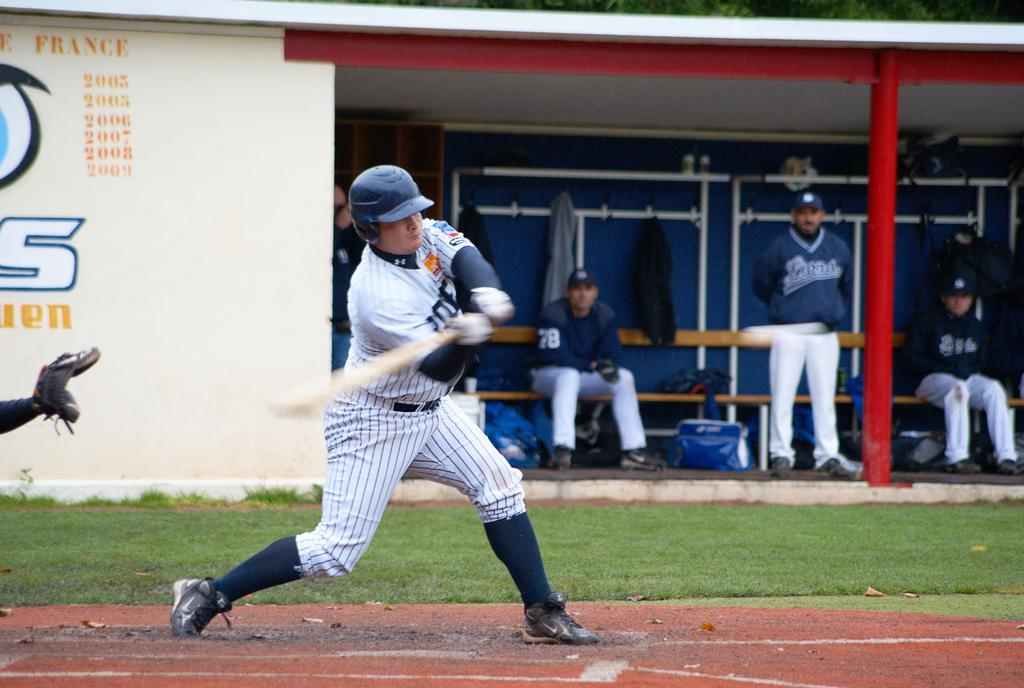Provide a one-sentence caption for the provided image. A batter is swinging with a wall that is labeled France 2003 2005 2006 2007 2008 2009. 